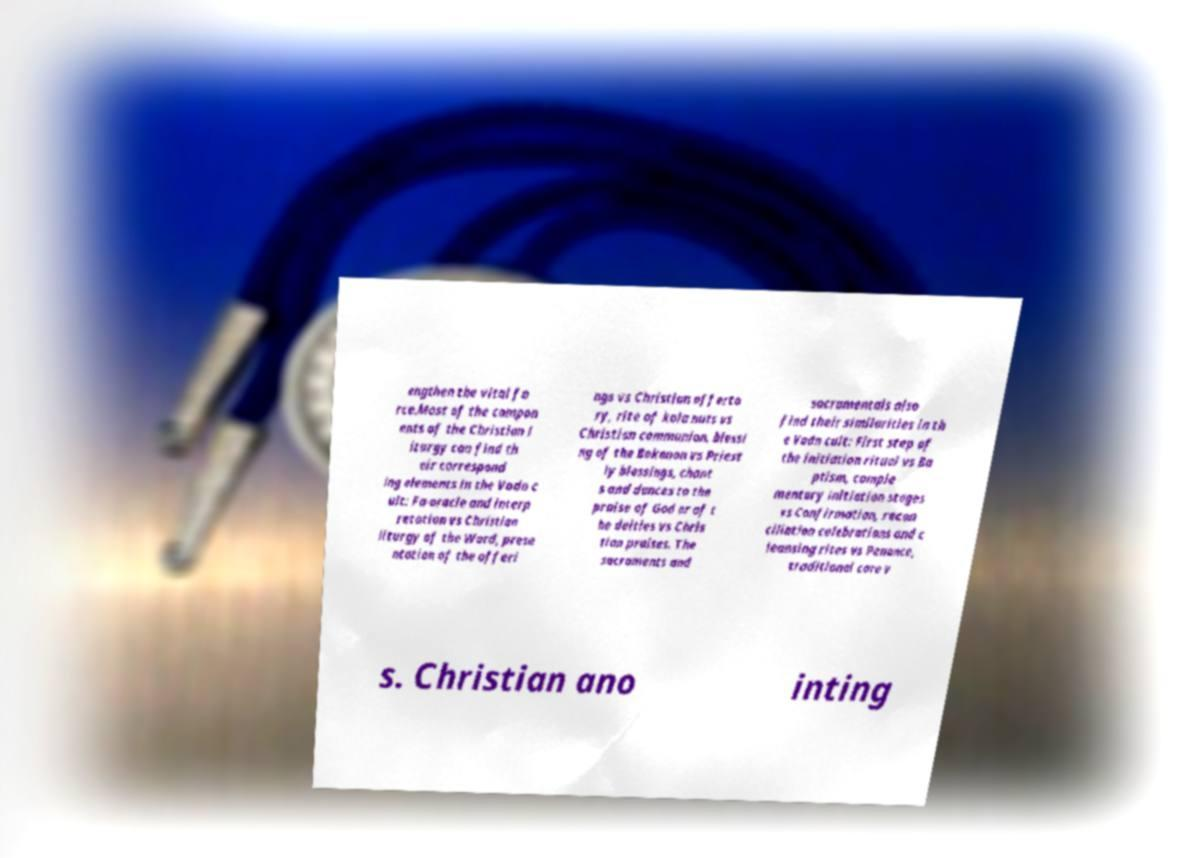Please read and relay the text visible in this image. What does it say? engthen the vital fo rce.Most of the compon ents of the Christian l iturgy can find th eir correspond ing elements in the Vodn c ult: Fa-oracle and interp retation vs Christian liturgy of the Word, prese ntation of the offeri ngs vs Christian offerto ry, rite of kola nuts vs Christian communion, blessi ng of the Bokonon vs Priest ly blessings, chant s and dances to the praise of God or of t he deities vs Chris tian praises. The sacraments and sacramentals also find their similarities in th e Vodn cult: First step of the initiation ritual vs Ba ptism, comple mentary initiation stages vs Confirmation, recon ciliation celebrations and c leansing rites vs Penance, traditional care v s. Christian ano inting 